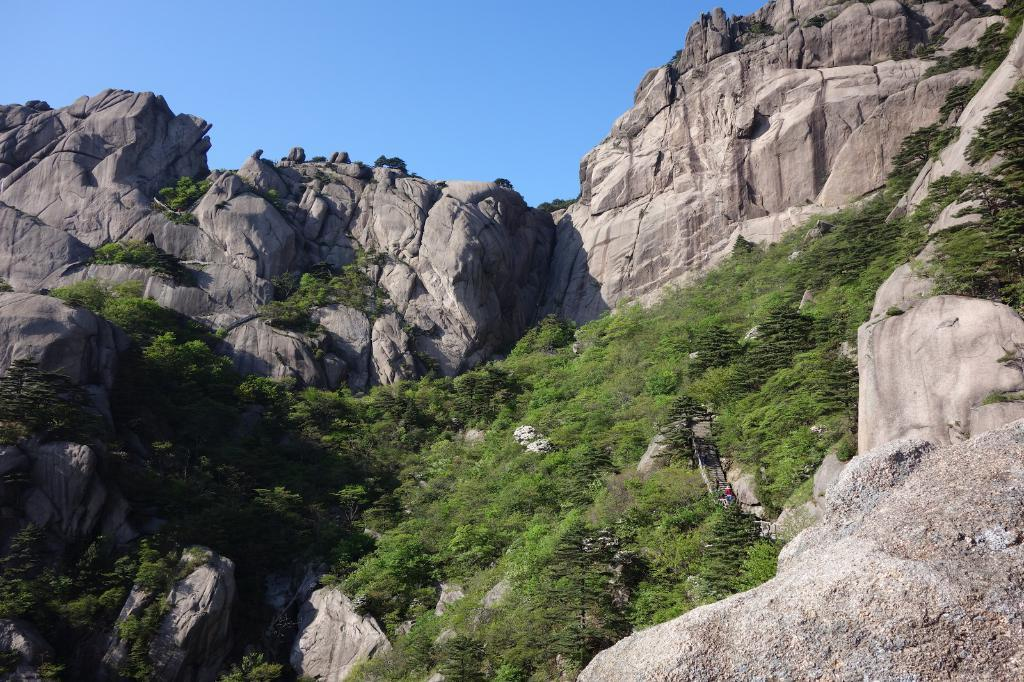Where was the image taken? The image was taken outdoors. What can be seen at the top of the image? The sky is visible at the top of the image. What are the main features in the middle of the image? There are many rocks in the middle of the image. What type of vegetation is present in the image? There are trees and plants in the image. What religious ceremony is taking place in the image? There is no religious ceremony present in the image. How many servants can be seen attending to the plants in the image? There are no servants present in the image. 